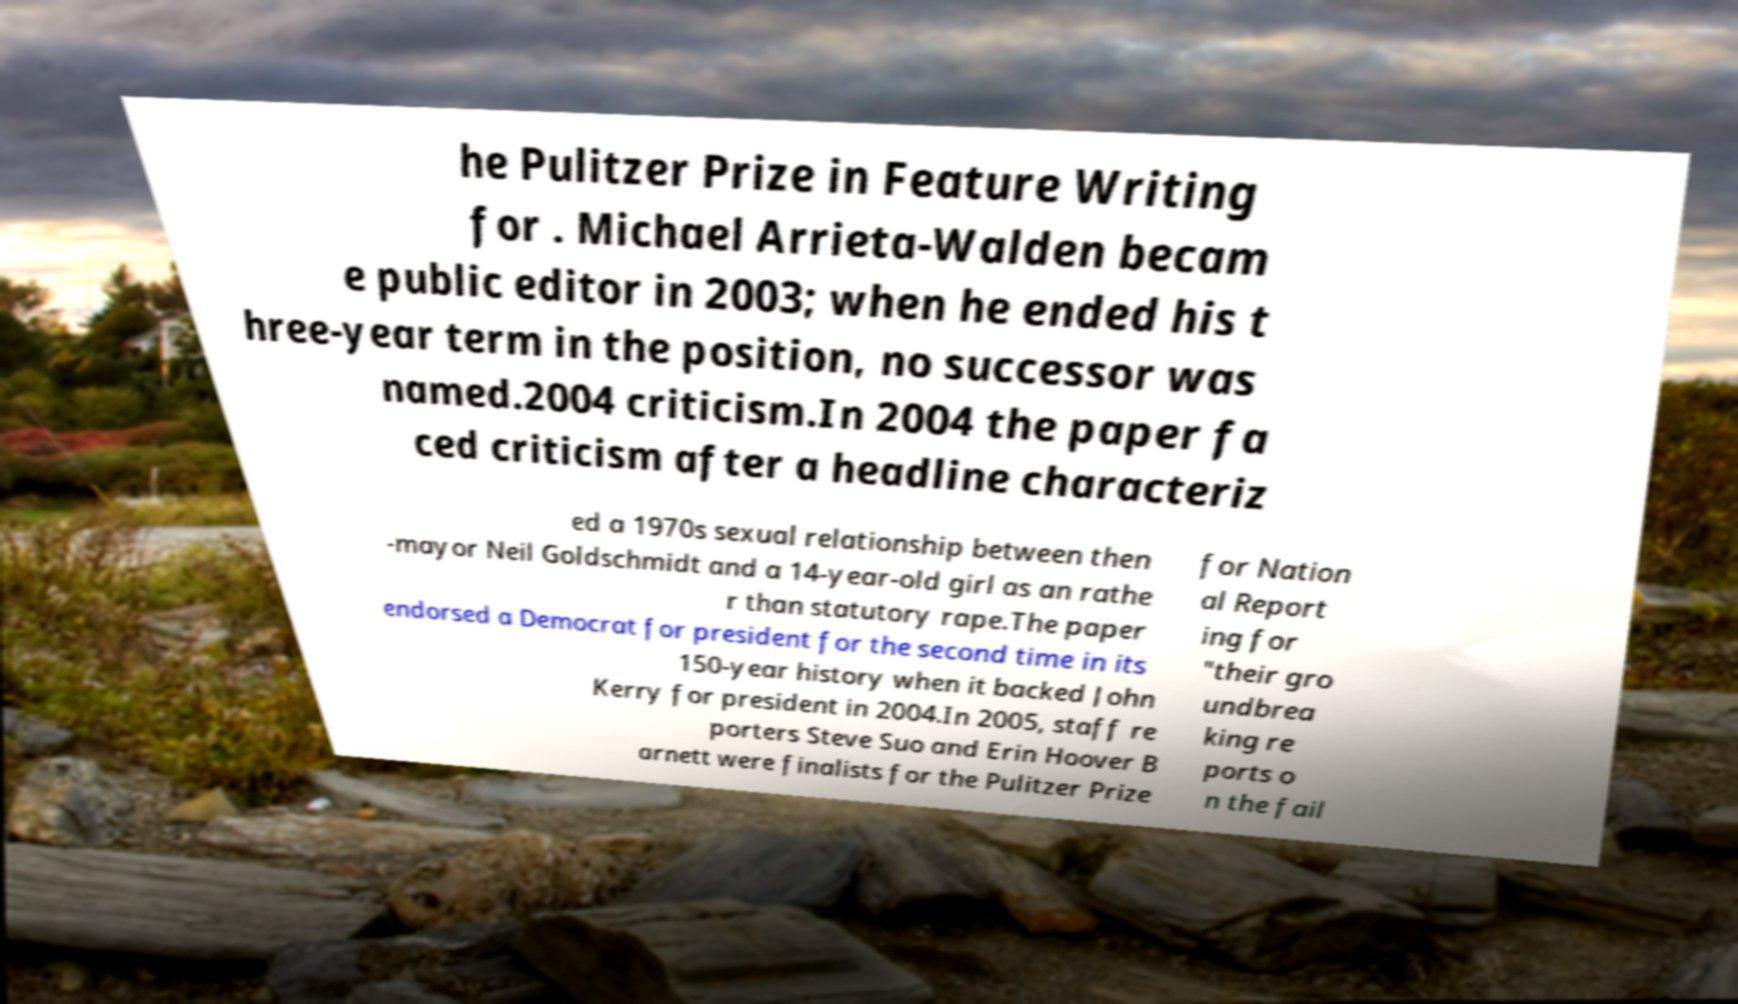I need the written content from this picture converted into text. Can you do that? he Pulitzer Prize in Feature Writing for . Michael Arrieta-Walden becam e public editor in 2003; when he ended his t hree-year term in the position, no successor was named.2004 criticism.In 2004 the paper fa ced criticism after a headline characteriz ed a 1970s sexual relationship between then -mayor Neil Goldschmidt and a 14-year-old girl as an rathe r than statutory rape.The paper endorsed a Democrat for president for the second time in its 150-year history when it backed John Kerry for president in 2004.In 2005, staff re porters Steve Suo and Erin Hoover B arnett were finalists for the Pulitzer Prize for Nation al Report ing for "their gro undbrea king re ports o n the fail 